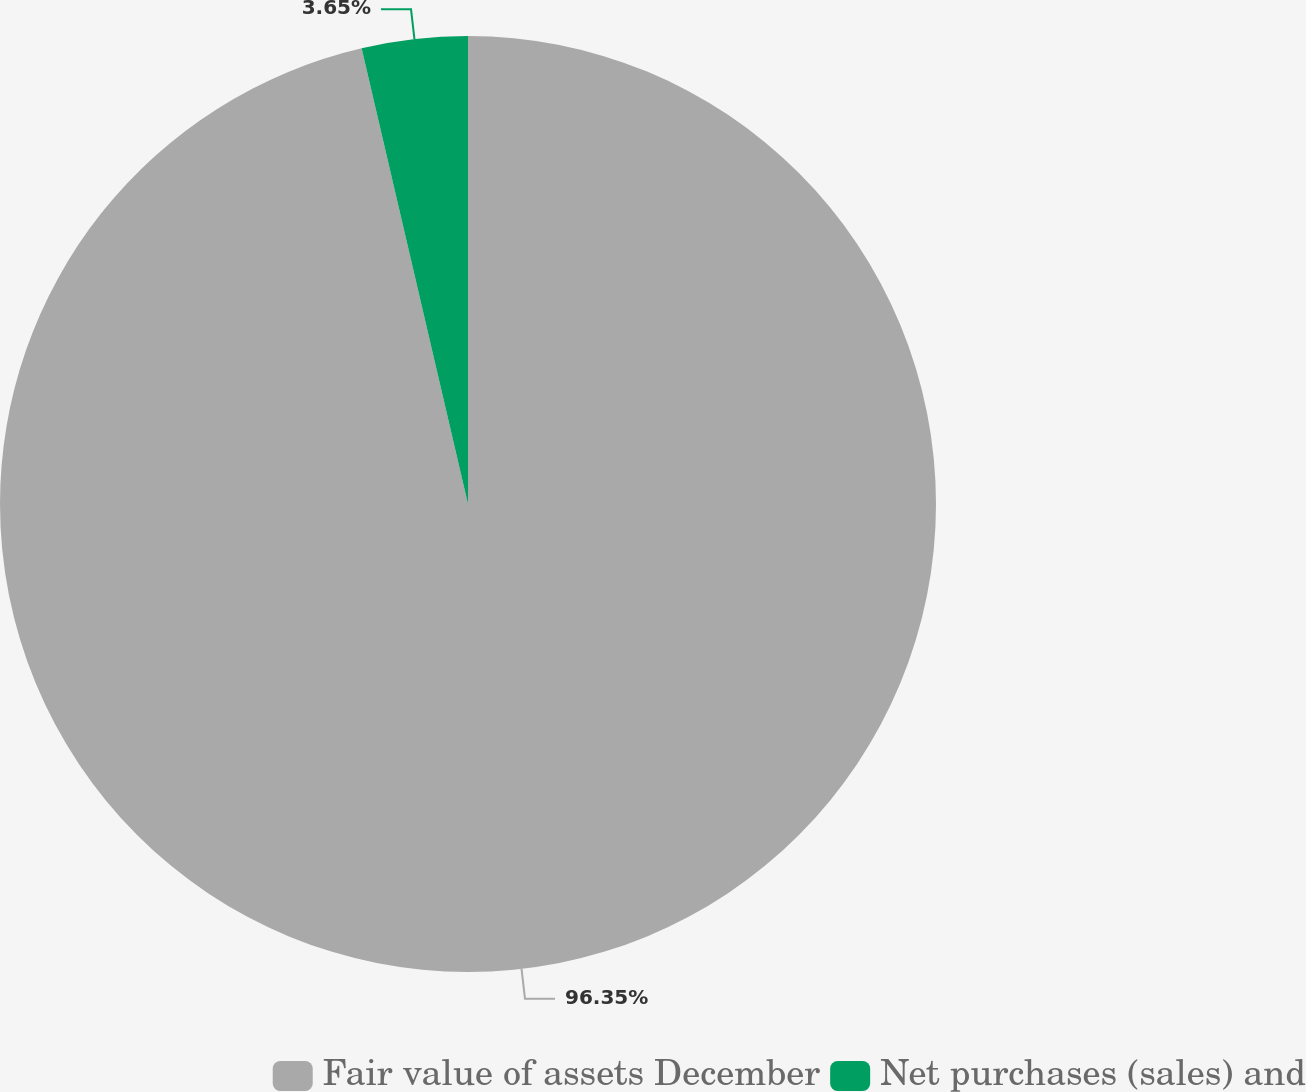<chart> <loc_0><loc_0><loc_500><loc_500><pie_chart><fcel>Fair value of assets December<fcel>Net purchases (sales) and<nl><fcel>96.35%<fcel>3.65%<nl></chart> 